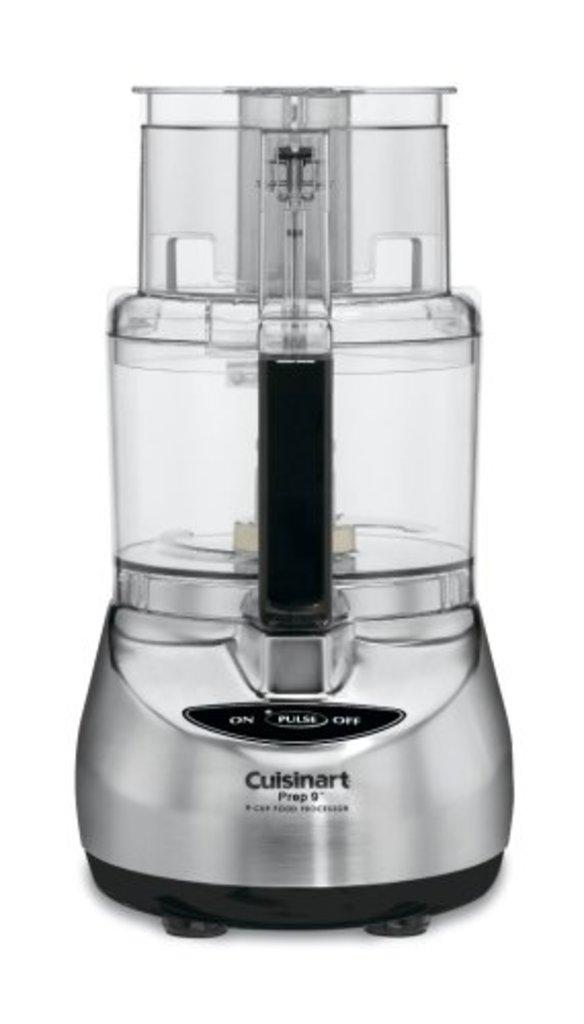<image>
Provide a brief description of the given image. a silver tone Cuisinart Prep 9 food processer. 